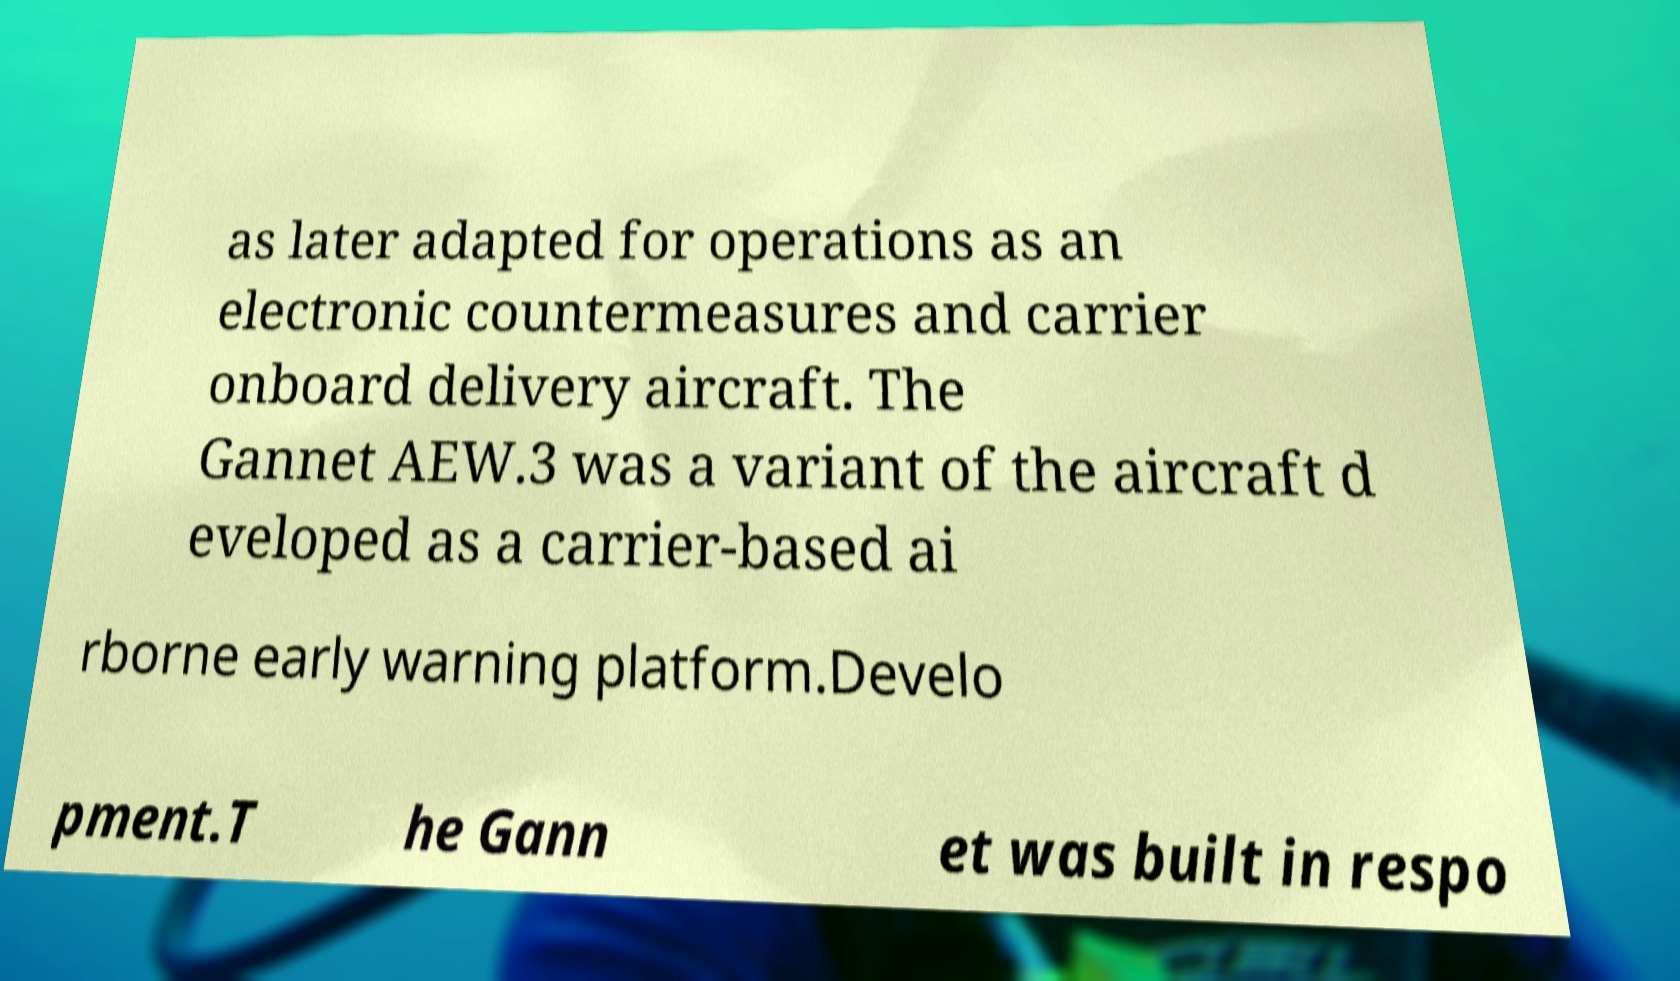There's text embedded in this image that I need extracted. Can you transcribe it verbatim? as later adapted for operations as an electronic countermeasures and carrier onboard delivery aircraft. The Gannet AEW.3 was a variant of the aircraft d eveloped as a carrier-based ai rborne early warning platform.Develo pment.T he Gann et was built in respo 